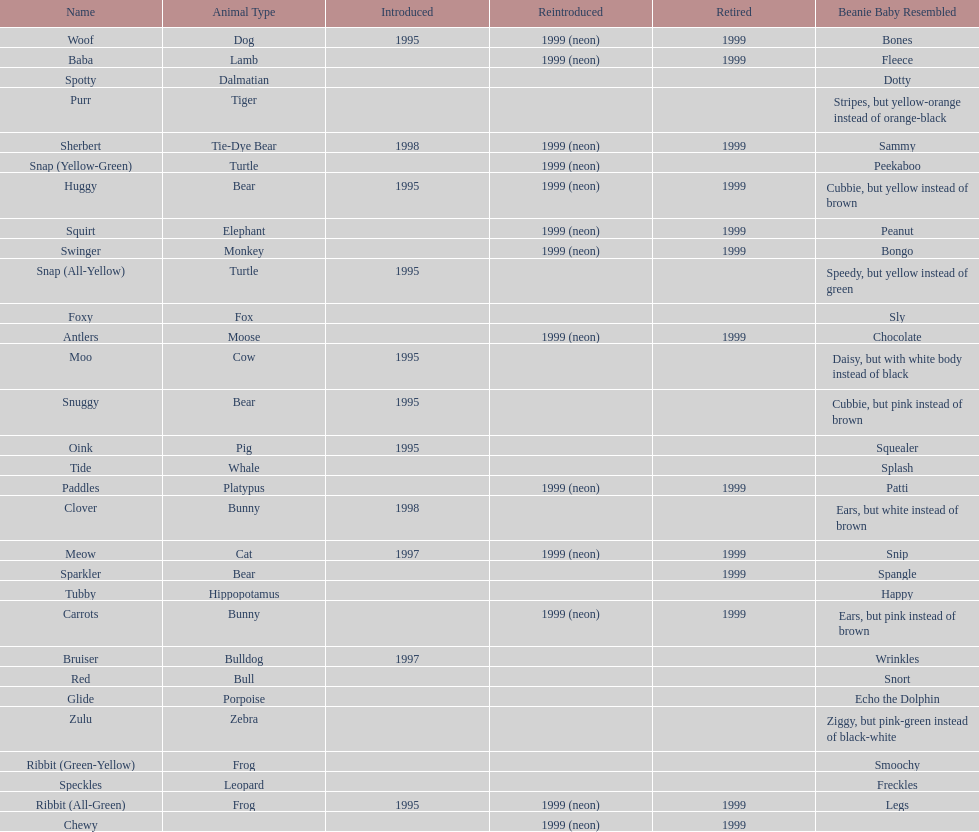How many total pillow pals were both reintroduced and retired in 1999? 12. 